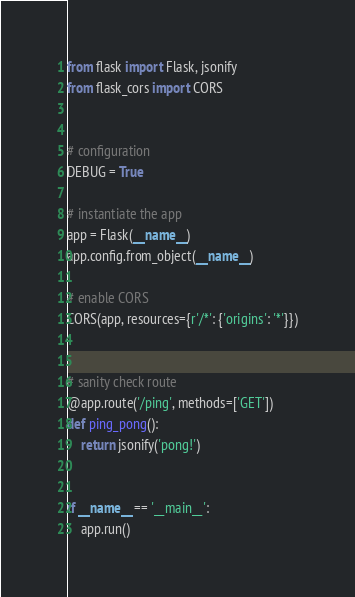<code> <loc_0><loc_0><loc_500><loc_500><_Python_>from flask import Flask, jsonify
from flask_cors import CORS


# configuration
DEBUG = True

# instantiate the app
app = Flask(__name__)
app.config.from_object(__name__)

# enable CORS
CORS(app, resources={r'/*': {'origins': '*'}})


# sanity check route
@app.route('/ping', methods=['GET'])
def ping_pong():
    return jsonify('pong!')


if __name__ == '__main__':
    app.run()
</code> 